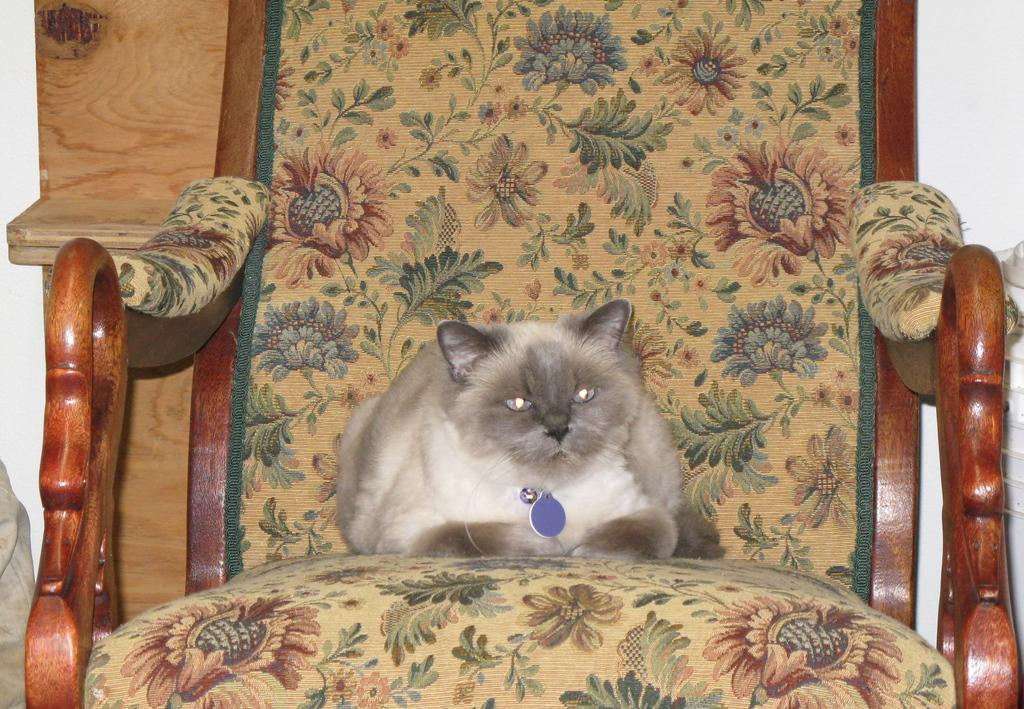What type of animal is in the image? There is a cat in the image. What is the cat doing in the image? The cat is sitting on a chair. What can be seen in the background of the image? There is wood material visible in the background of the image. What type of flower is the cat holding in the image? There is no flower present in the image, and the cat is not holding anything. 